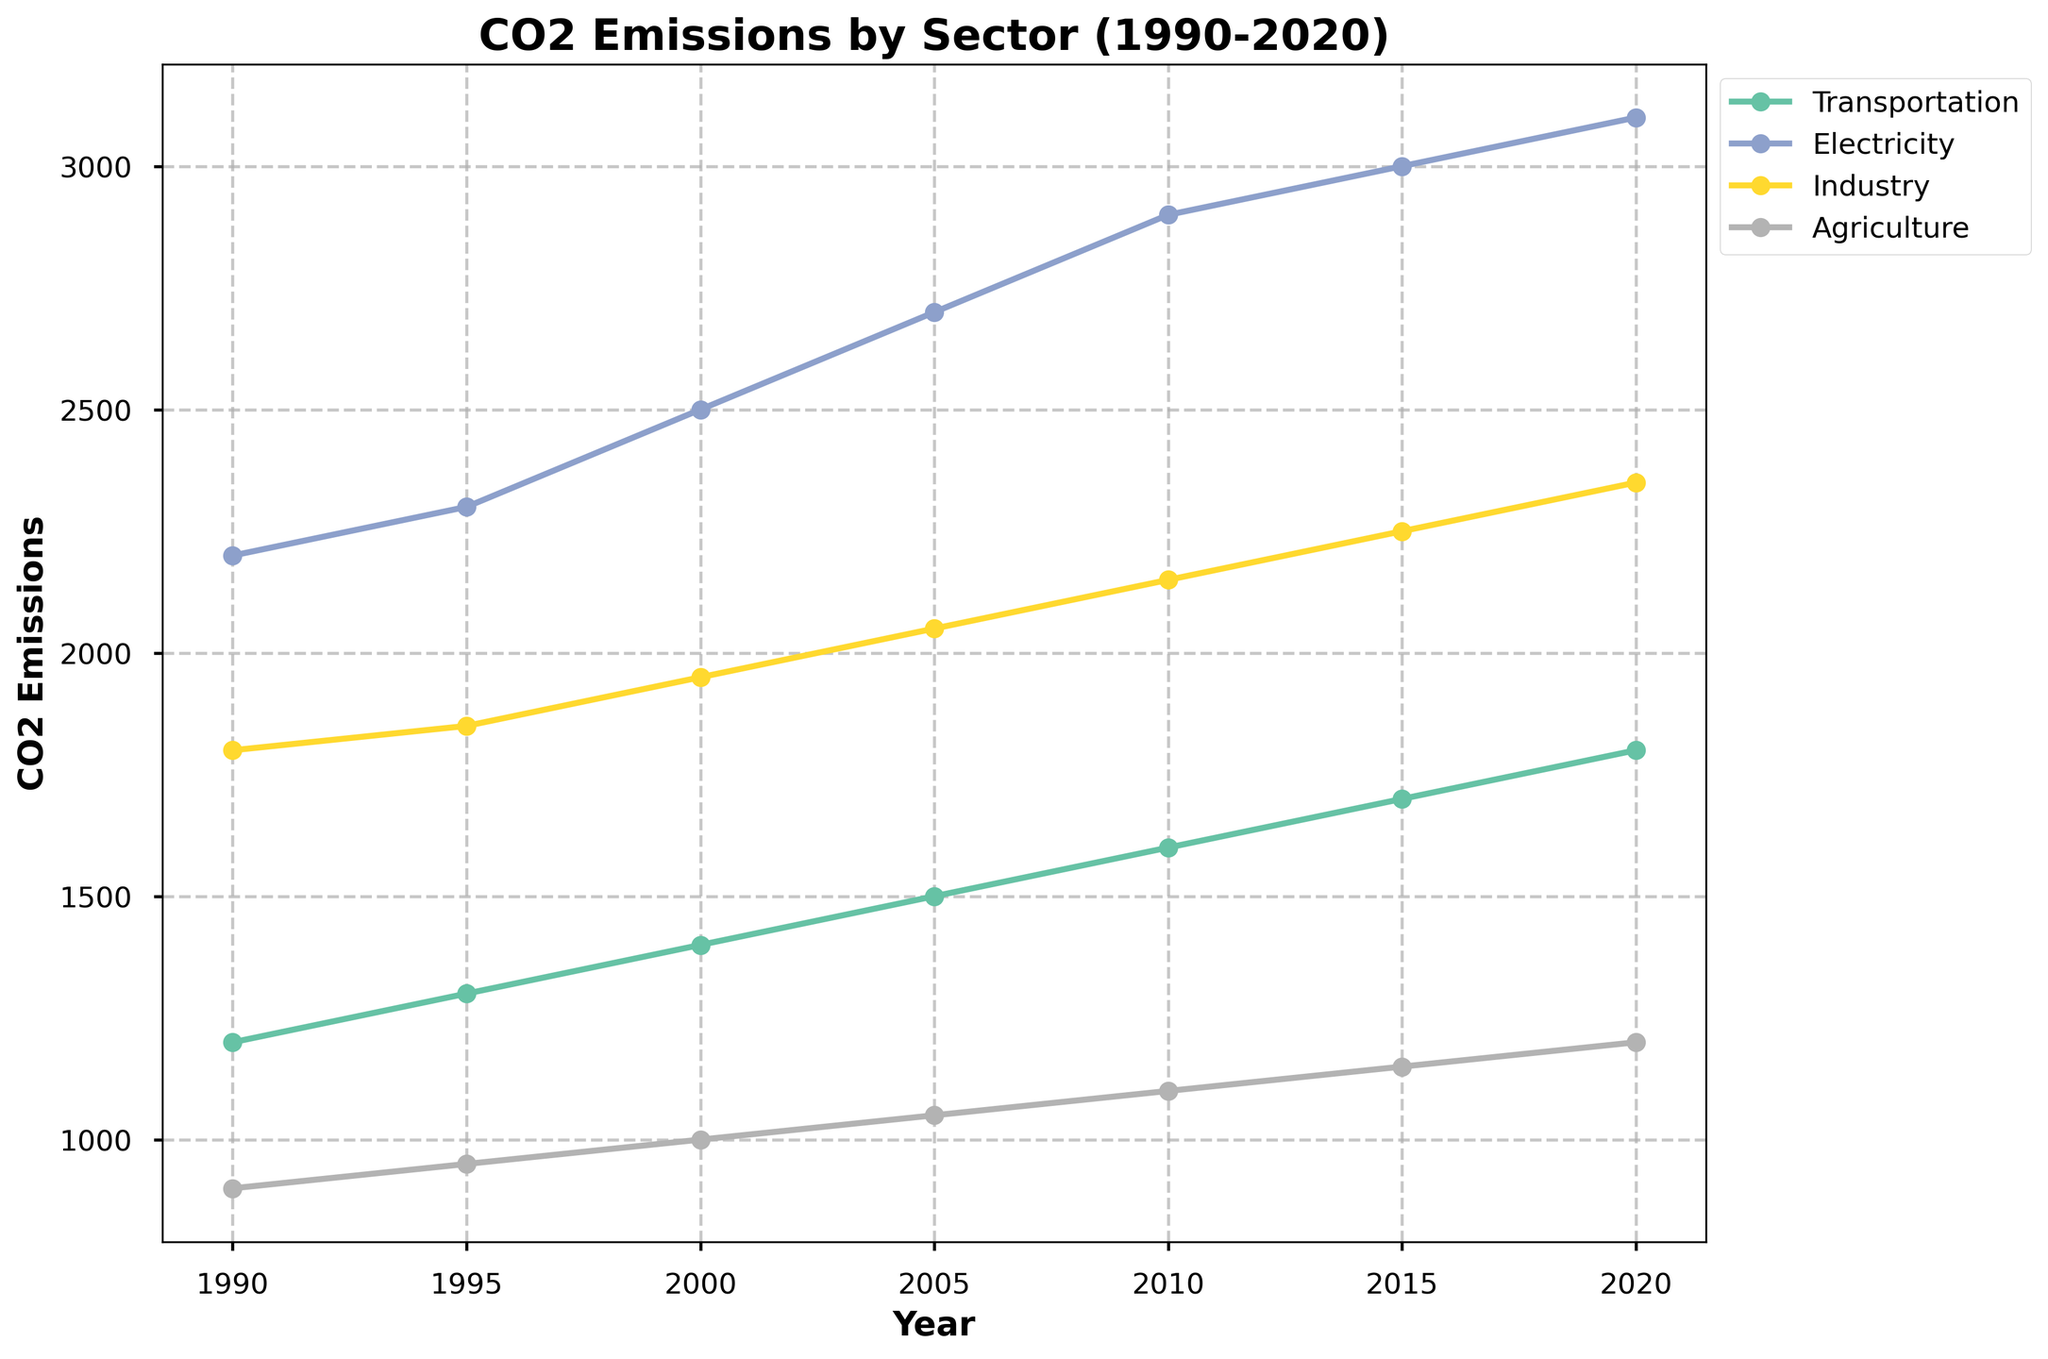What is the title of the figure? The title of the figure is located at the top and states the purpose of the chart, which is to show CO2 emissions by sector over the specified years.
Answer: CO2 Emissions by Sector (1990-2020) Which sector had the highest CO2 emissions in 2020? Look at the endpoints of the lines corresponding to the year 2020 and identify which one is the highest.
Answer: Electricity What years are displayed on the x-axis? The years are shown along the horizontal axis and represent the time period the data covers.
Answer: 1990, 1995, 2000, 2005, 2010, 2015, 2020 What is the CO2 emission value for Transportation in 2010? Locate the line corresponding to the Transportation sector, then follow the line until the year 2010, and find the corresponding CO2 emission value on the y-axis.
Answer: 1600 How many sectors are presented in the figure? Each unique line in the plot represents a sector. Count the number of different lines or check the legend.
Answer: 4 Which sector experienced the largest increase in CO2 emissions between 1990 and 2020? Identify the starting and ending CO2 emission values for each sector, then compute the difference (2020 value - 1990 value) for each sector and find the largest increase.
Answer: Electricity Between 1990 and 2020, did any sector show a decrease in CO2 emissions? Compare the CO2 emissions for each sector at the earliest year (1990) and the latest year (2020) and check if any sector shows a negative change.
Answer: No Which sector had the least variation in CO2 emissions over the displayed time period? Calculate the range (maximum - minimum) of CO2 emissions for each sector, and identify the sector with the smallest range.
Answer: Agriculture What is the average CO2 emission for the Industry sector across all years? Sum the CO2 emissions for the Industry sector for all displayed years, then divide by the number of years (i.e., average = sum / count). Industry values are 1800, 1850, 1950, 2050, 2150, 2250, and 2350 across 7 years. The sum is 14400, and the average is 14400 / 7.
Answer: 2057.14 In which year did the Agriculture sector surpass 1000 CO2 emissions? Follow the line corresponding to the Agriculture sector and identify the first year where the value exceeds 1000 on the y-axis.
Answer: 2000 